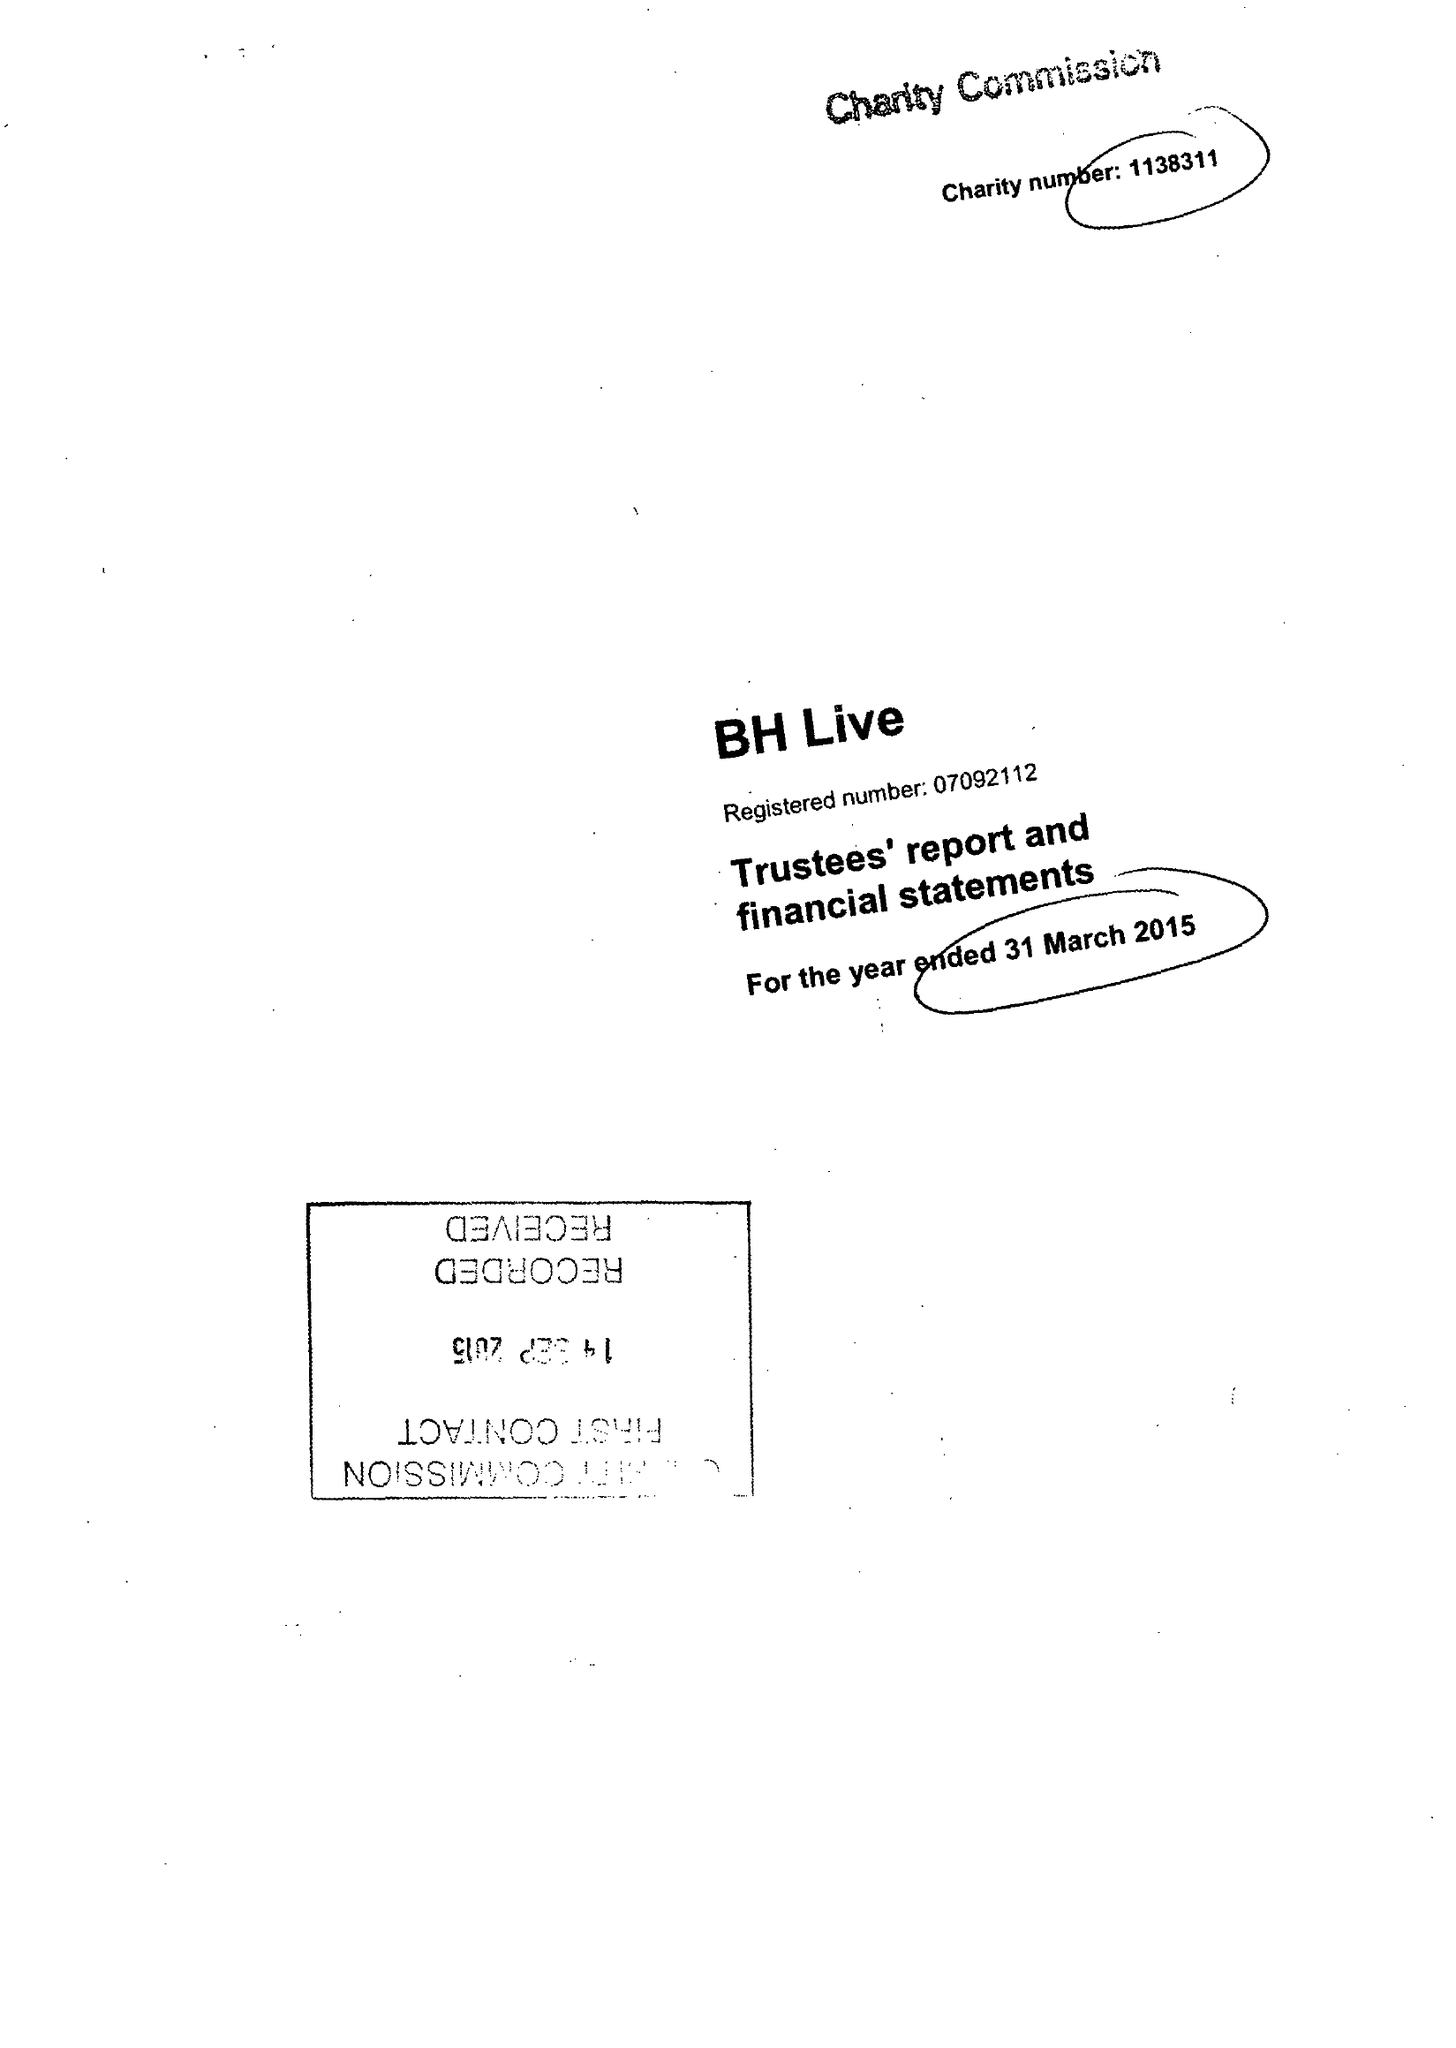What is the value for the charity_number?
Answer the question using a single word or phrase. 1138311 